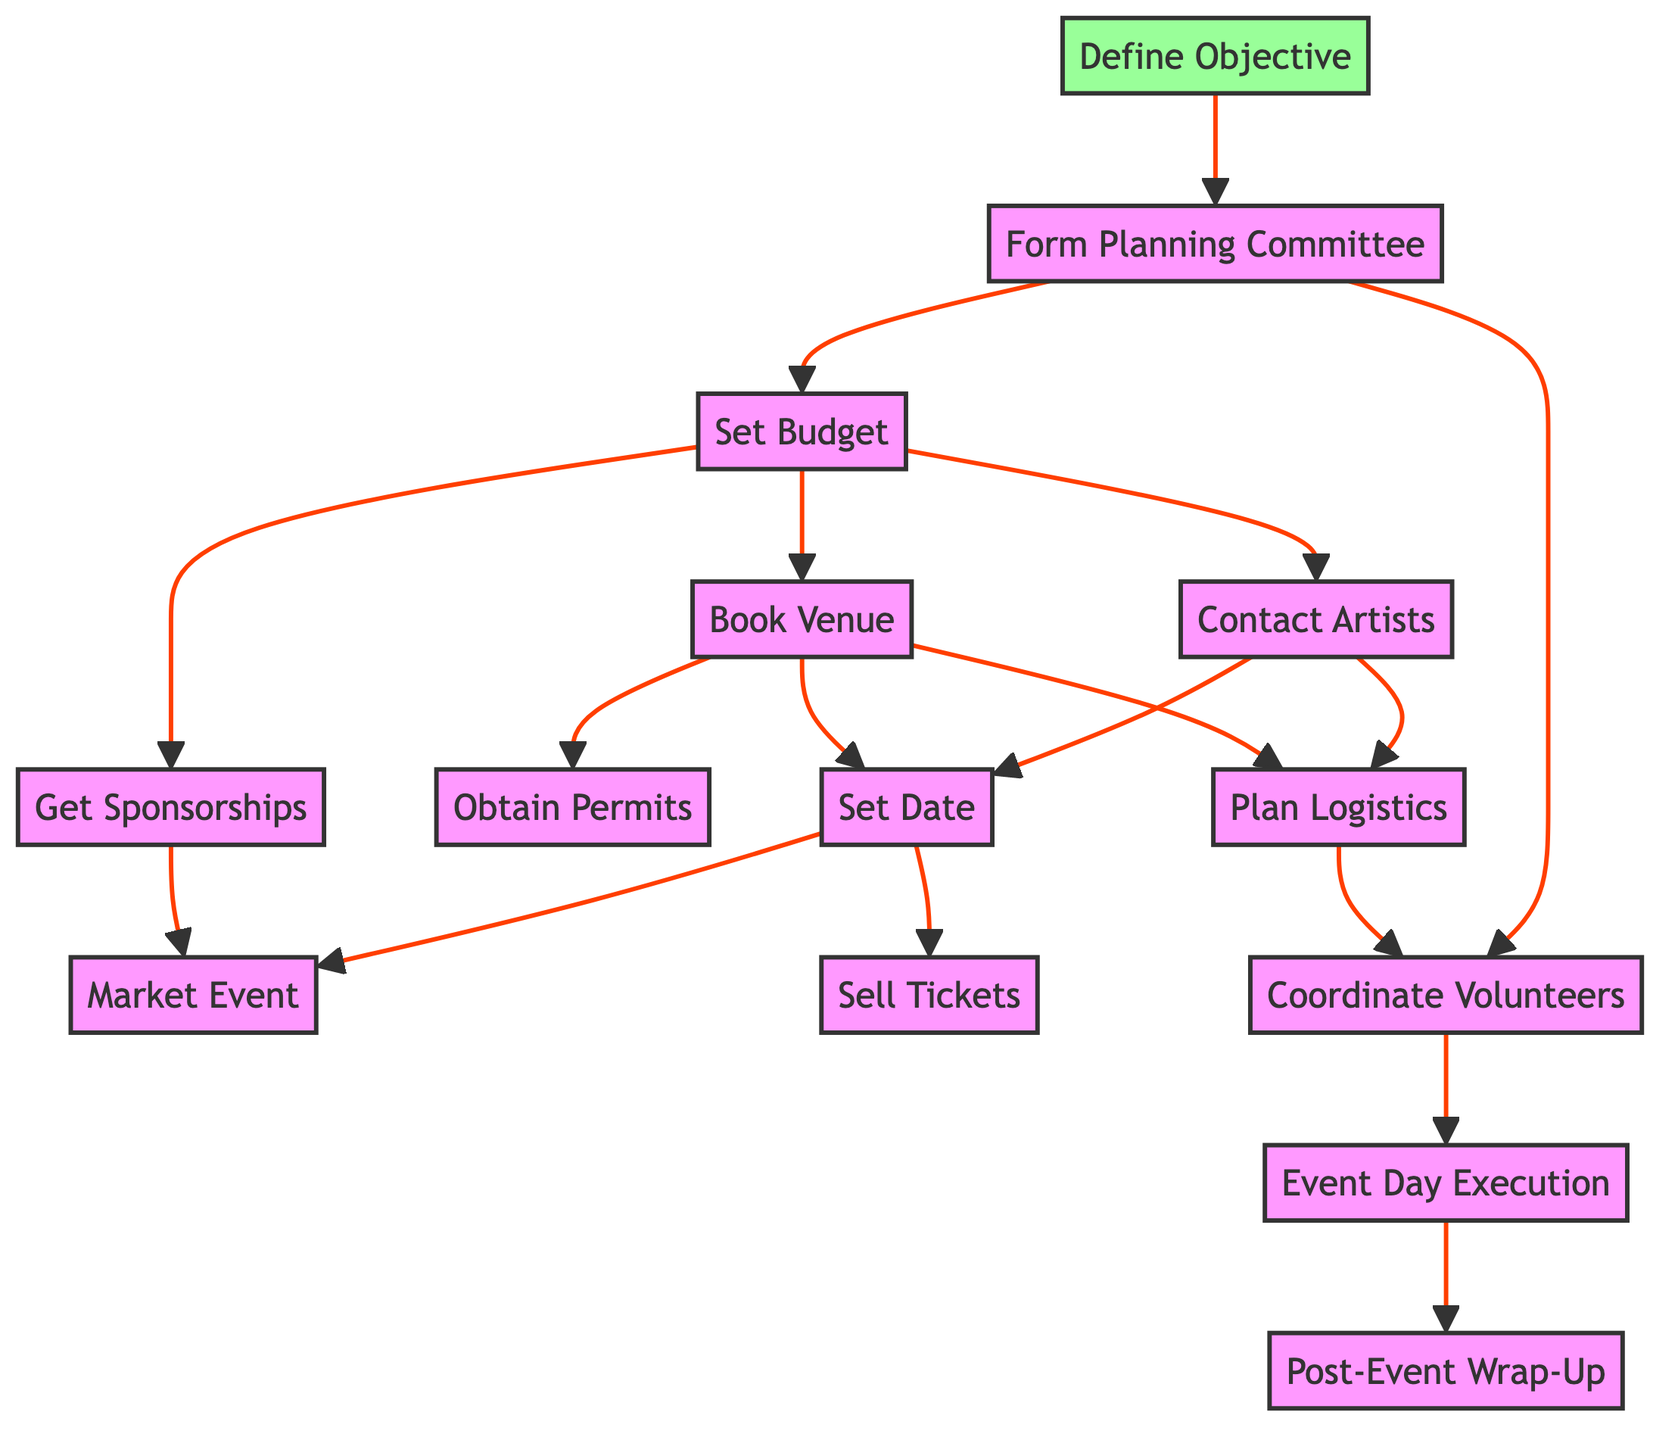What is the first task in the process? The diagram starts with the "Define Objective," which is the first node and indicates the beginning of the overall charity rock concert organization process.
Answer: Define Objective How many main tasks must be completed after "Set Budget"? From "Set Budget," there are three subsequent tasks: "Book Venue," "Contact Artists," and "Get Sponsorships." This means there are three tasks to follow.
Answer: 3 Which task comes after "Coordinate Volunteers"? The flow chart indicates that "Event Day Execution" directly follows "Coordinate Volunteers," indicating it is the next step.
Answer: Event Day Execution What are the dependencies for the task "Obtain Permits"? The only task that needs to be completed before "Obtain Permits" is "Book Venue," meaning this is the dependency that must be fulfilled first.
Answer: Book Venue How many tasks can occur concurrently after "Set Date"? After "Set Date," there are two tasks that can occur concurrently: "Market Event" and "Sell Tickets," indicating that both processes can be developed at the same time.
Answer: 2 Which tasks require artist contact before they can start? The tasks "Set Date" and "Plan Logistics" require "Contact Artists" to be completed first as they are dependent on it for their execution.
Answer: Set Date; Plan Logistics What is the last task in the process flow? The flow chart culminates with "Post-Event Wrap-Up," indicating that this is the final step in the charity rock concert organization process.
Answer: Post-Event Wrap-Up What is the second task in the process? Following the first task "Define Objective," the second task that occurs is "Form Planning Committee," which comes immediately afterward in the flow.
Answer: Form Planning Committee Which task must be completed after "Market Event"? "Sell Tickets" is the task that must follow "Market Event," as indicated in the diagram's flow connection showing dependencies after marketing.
Answer: Sell Tickets 